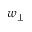Convert formula to latex. <formula><loc_0><loc_0><loc_500><loc_500>w _ { \perp }</formula> 